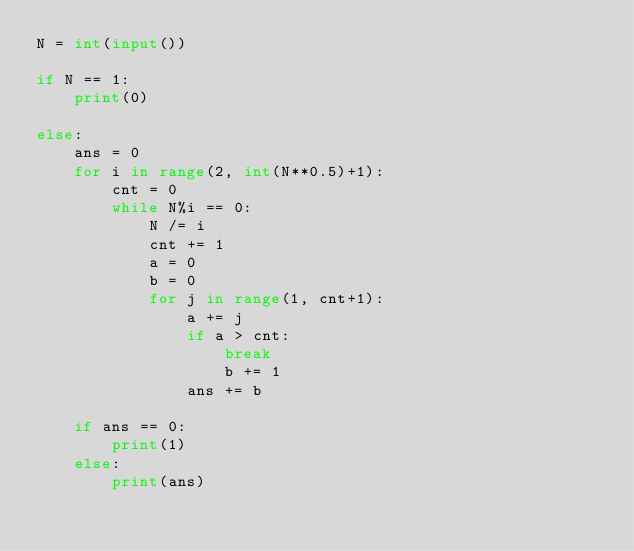Convert code to text. <code><loc_0><loc_0><loc_500><loc_500><_Python_>N = int(input())

if N == 1:
    print(0)

else:
    ans = 0
    for i in range(2, int(N**0.5)+1):
        cnt = 0
        while N%i == 0:
            N /= i
            cnt += 1
            a = 0
            b = 0
            for j in range(1, cnt+1):
                a += j
                if a > cnt:
                    break
                    b += 1    
                ans += b

    if ans == 0:
        print(1)
    else:
        print(ans)</code> 